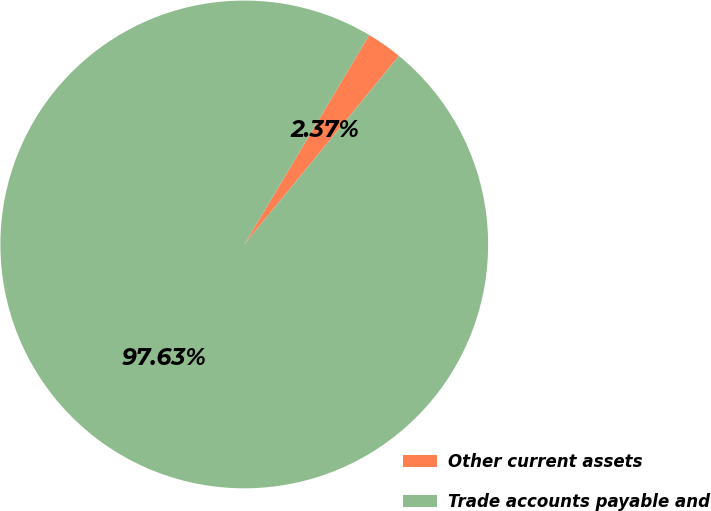Convert chart to OTSL. <chart><loc_0><loc_0><loc_500><loc_500><pie_chart><fcel>Other current assets<fcel>Trade accounts payable and<nl><fcel>2.37%<fcel>97.63%<nl></chart> 